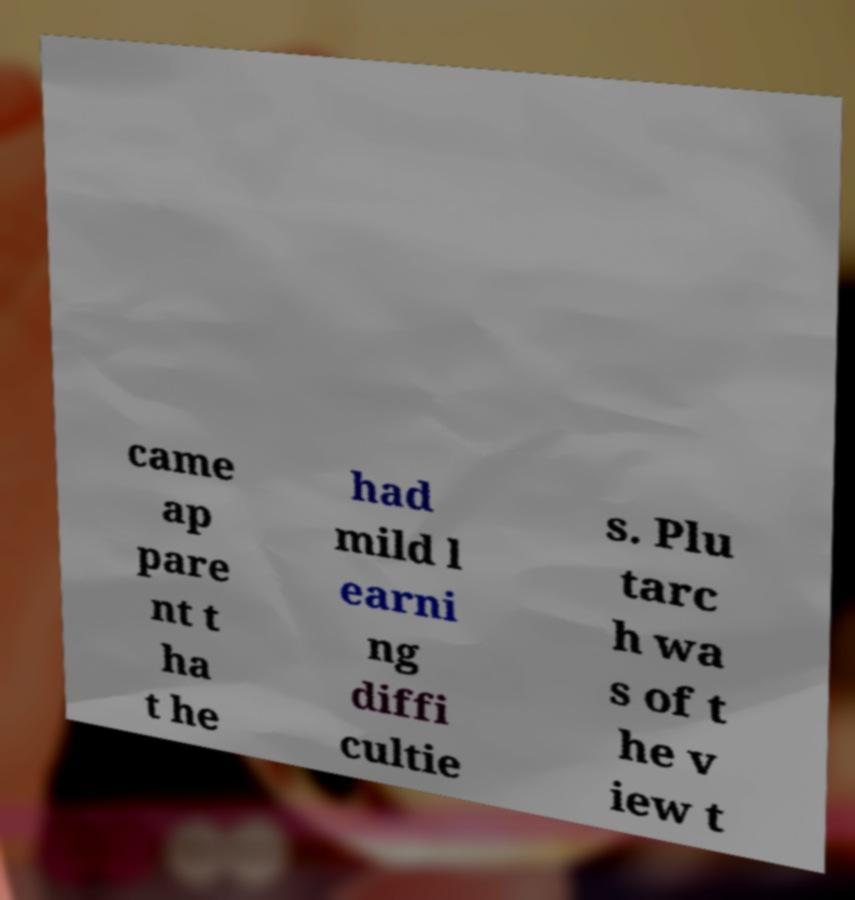For documentation purposes, I need the text within this image transcribed. Could you provide that? came ap pare nt t ha t he had mild l earni ng diffi cultie s. Plu tarc h wa s of t he v iew t 